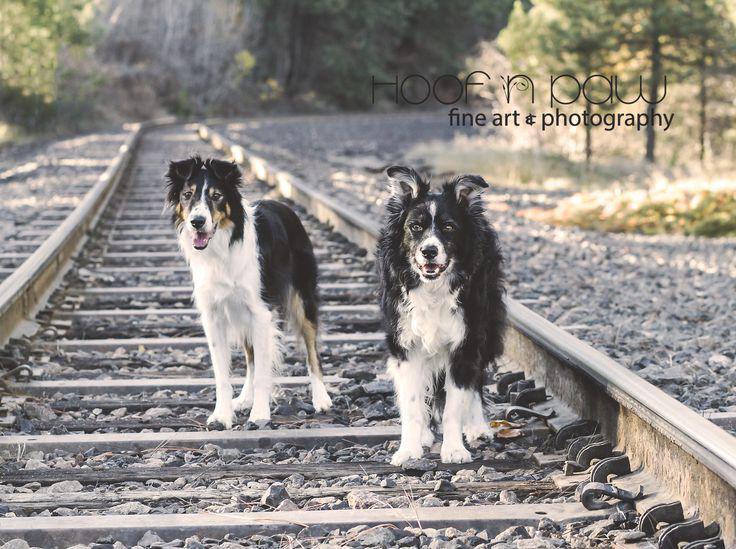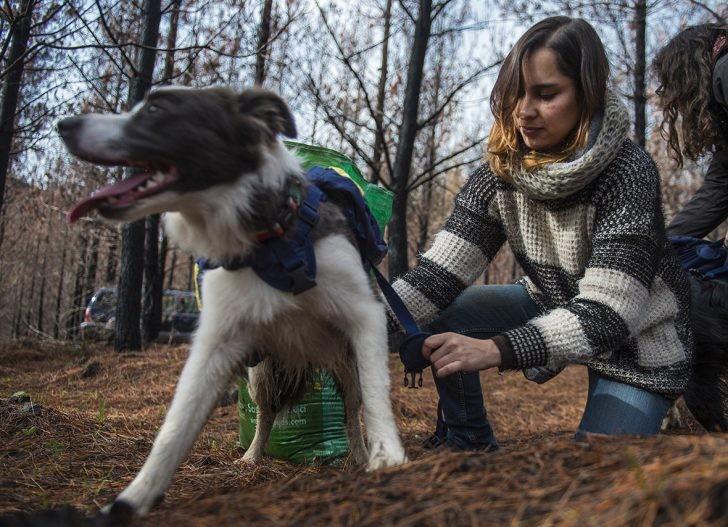The first image is the image on the left, the second image is the image on the right. Examine the images to the left and right. Is the description "The left image contains two dogs that are not wearing vests, and the right image features a girl in a striped sweater with at least one dog wearing a vest pack." accurate? Answer yes or no. Yes. The first image is the image on the left, the second image is the image on the right. For the images displayed, is the sentence "One or more of the images has three dogs." factually correct? Answer yes or no. No. 